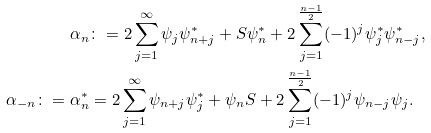Convert formula to latex. <formula><loc_0><loc_0><loc_500><loc_500>\alpha _ { n } & \colon = 2 \sum _ { j = 1 } ^ { \infty } \psi _ { j } \psi ^ { * } _ { n + j } + S \psi ^ { * } _ { n } + 2 \sum _ { j = 1 } ^ { \frac { n - 1 } { 2 } } ( - 1 ) ^ { j } \psi ^ { * } _ { j } \psi ^ { * } _ { n - j } , \\ \alpha _ { - n } \colon = \alpha ^ { * } _ { n } & = 2 \sum _ { j = 1 } ^ { \infty } \psi _ { n + j } \psi ^ { * } _ { j } + \psi _ { n } S + 2 \sum _ { j = 1 } ^ { \frac { n - 1 } { 2 } } ( - 1 ) ^ { j } \psi _ { n - j } \psi _ { j } .</formula> 